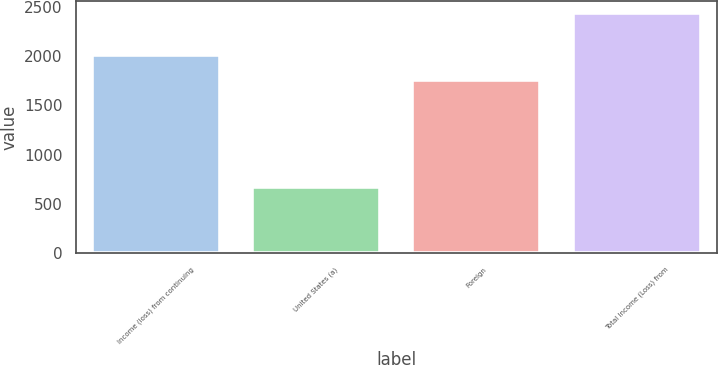Convert chart. <chart><loc_0><loc_0><loc_500><loc_500><bar_chart><fcel>Income (loss) from continuing<fcel>United States (a)<fcel>Foreign<fcel>Total Income (Loss) from<nl><fcel>2014<fcel>676<fcel>1760<fcel>2436<nl></chart> 